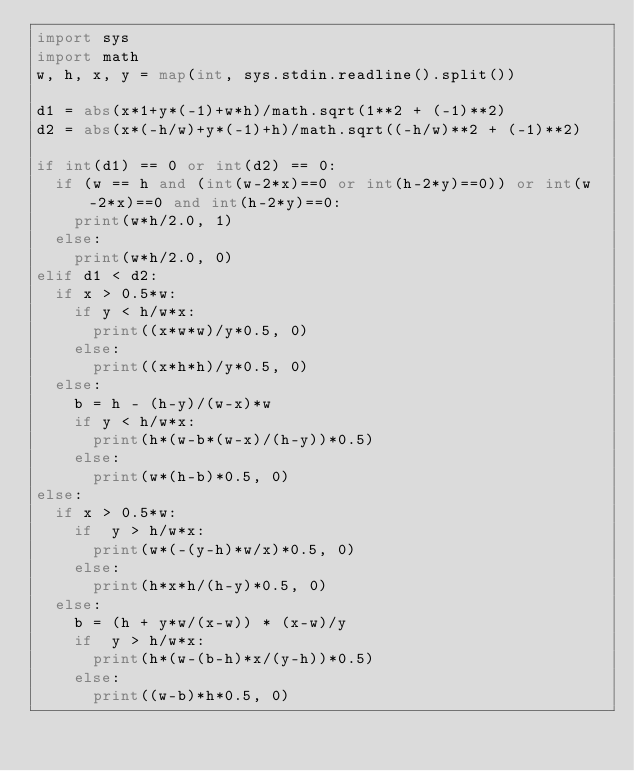Convert code to text. <code><loc_0><loc_0><loc_500><loc_500><_Python_>import sys
import math
w, h, x, y = map(int, sys.stdin.readline().split())

d1 = abs(x*1+y*(-1)+w*h)/math.sqrt(1**2 + (-1)**2)
d2 = abs(x*(-h/w)+y*(-1)+h)/math.sqrt((-h/w)**2 + (-1)**2)

if int(d1) == 0 or int(d2) == 0:
  if (w == h and (int(w-2*x)==0 or int(h-2*y)==0)) or int(w-2*x)==0 and int(h-2*y)==0:
    print(w*h/2.0, 1)
  else:
    print(w*h/2.0, 0)
elif d1 < d2:
  if x > 0.5*w:
    if y < h/w*x:
      print((x*w*w)/y*0.5, 0)
    else:
      print((x*h*h)/y*0.5, 0)
  else:
    b = h - (h-y)/(w-x)*w
    if y < h/w*x:
      print(h*(w-b*(w-x)/(h-y))*0.5)
    else:
      print(w*(h-b)*0.5, 0)
else:
  if x > 0.5*w:
    if  y > h/w*x:
      print(w*(-(y-h)*w/x)*0.5, 0)
    else:
      print(h*x*h/(h-y)*0.5, 0)
  else:
    b = (h + y*w/(x-w)) * (x-w)/y
    if  y > h/w*x:
      print(h*(w-(b-h)*x/(y-h))*0.5)
    else:
      print((w-b)*h*0.5, 0)</code> 